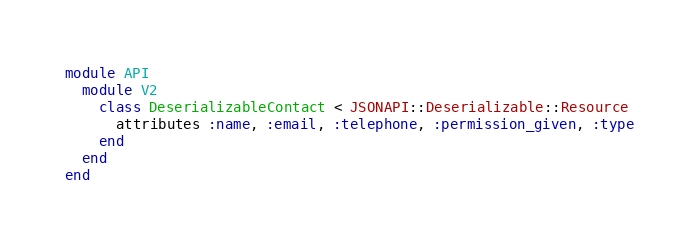Convert code to text. <code><loc_0><loc_0><loc_500><loc_500><_Ruby_>module API
  module V2
    class DeserializableContact < JSONAPI::Deserializable::Resource
      attributes :name, :email, :telephone, :permission_given, :type
    end
  end
end
</code> 